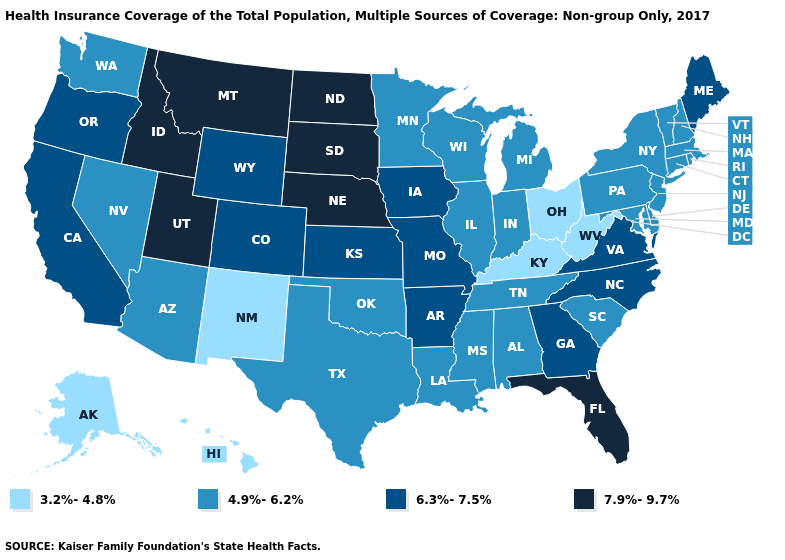What is the value of Illinois?
Answer briefly. 4.9%-6.2%. What is the highest value in states that border Alabama?
Write a very short answer. 7.9%-9.7%. What is the value of Alaska?
Keep it brief. 3.2%-4.8%. Does Oregon have the lowest value in the USA?
Quick response, please. No. Name the states that have a value in the range 3.2%-4.8%?
Concise answer only. Alaska, Hawaii, Kentucky, New Mexico, Ohio, West Virginia. Is the legend a continuous bar?
Concise answer only. No. Name the states that have a value in the range 3.2%-4.8%?
Answer briefly. Alaska, Hawaii, Kentucky, New Mexico, Ohio, West Virginia. Name the states that have a value in the range 7.9%-9.7%?
Write a very short answer. Florida, Idaho, Montana, Nebraska, North Dakota, South Dakota, Utah. Name the states that have a value in the range 7.9%-9.7%?
Give a very brief answer. Florida, Idaho, Montana, Nebraska, North Dakota, South Dakota, Utah. How many symbols are there in the legend?
Short answer required. 4. Name the states that have a value in the range 3.2%-4.8%?
Short answer required. Alaska, Hawaii, Kentucky, New Mexico, Ohio, West Virginia. Name the states that have a value in the range 6.3%-7.5%?
Answer briefly. Arkansas, California, Colorado, Georgia, Iowa, Kansas, Maine, Missouri, North Carolina, Oregon, Virginia, Wyoming. What is the highest value in the USA?
Give a very brief answer. 7.9%-9.7%. Which states have the lowest value in the Northeast?
Keep it brief. Connecticut, Massachusetts, New Hampshire, New Jersey, New York, Pennsylvania, Rhode Island, Vermont. Does Rhode Island have the same value as Wisconsin?
Short answer required. Yes. 